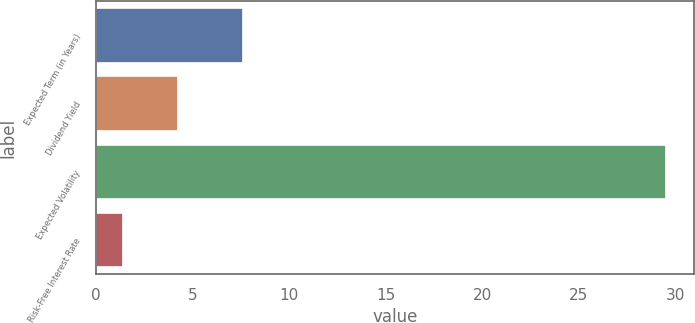Convert chart to OTSL. <chart><loc_0><loc_0><loc_500><loc_500><bar_chart><fcel>Expected Term (in Years)<fcel>Dividend Yield<fcel>Expected Volatility<fcel>Risk-Free Interest Rate<nl><fcel>7.6<fcel>4.24<fcel>29.5<fcel>1.43<nl></chart> 